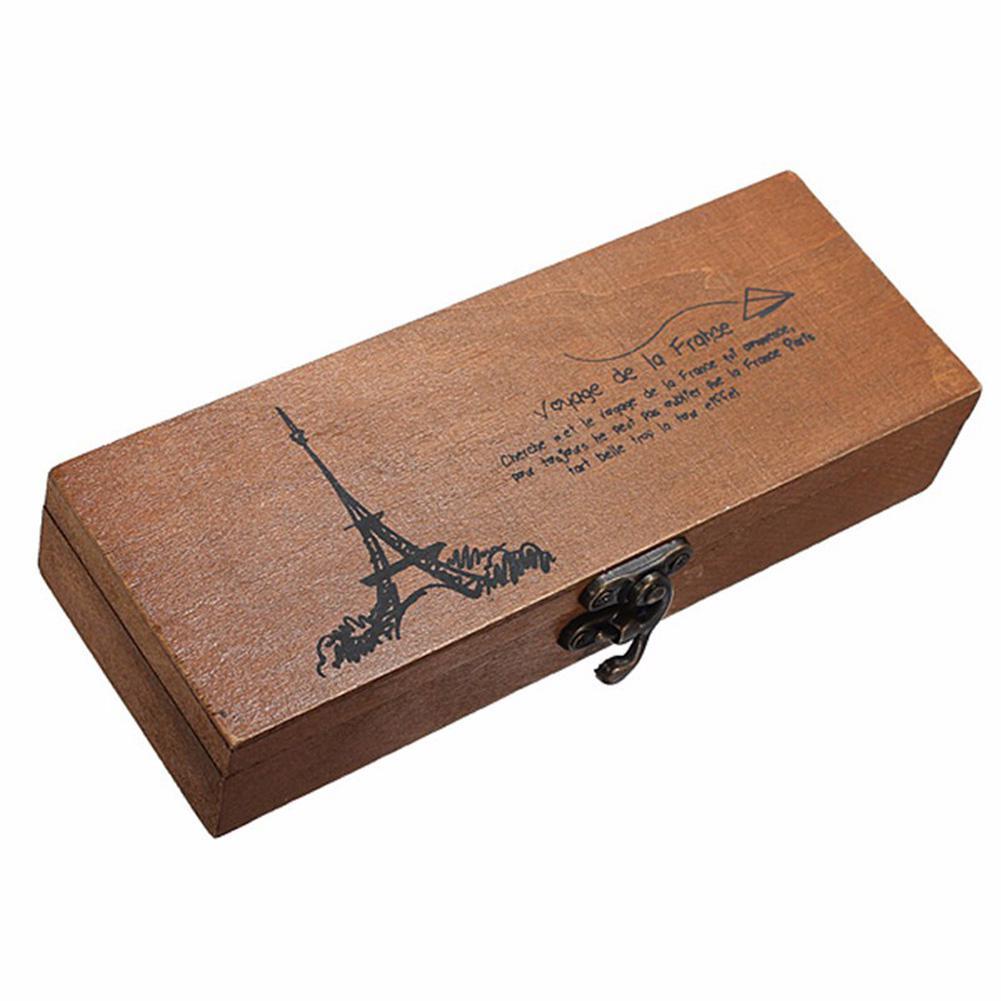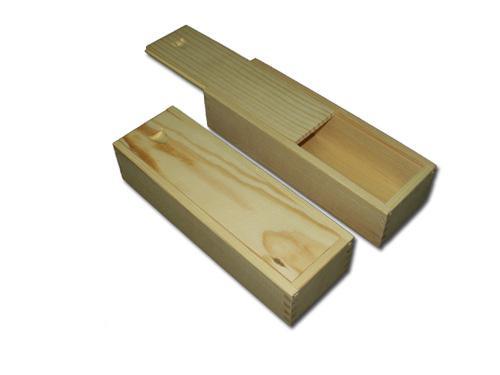The first image is the image on the left, the second image is the image on the right. Given the left and right images, does the statement "One of the pencil cases pictured has an Eiffel tower imprint." hold true? Answer yes or no. Yes. The first image is the image on the left, the second image is the image on the right. Assess this claim about the two images: "The case is open in the image on the lef.". Correct or not? Answer yes or no. No. 